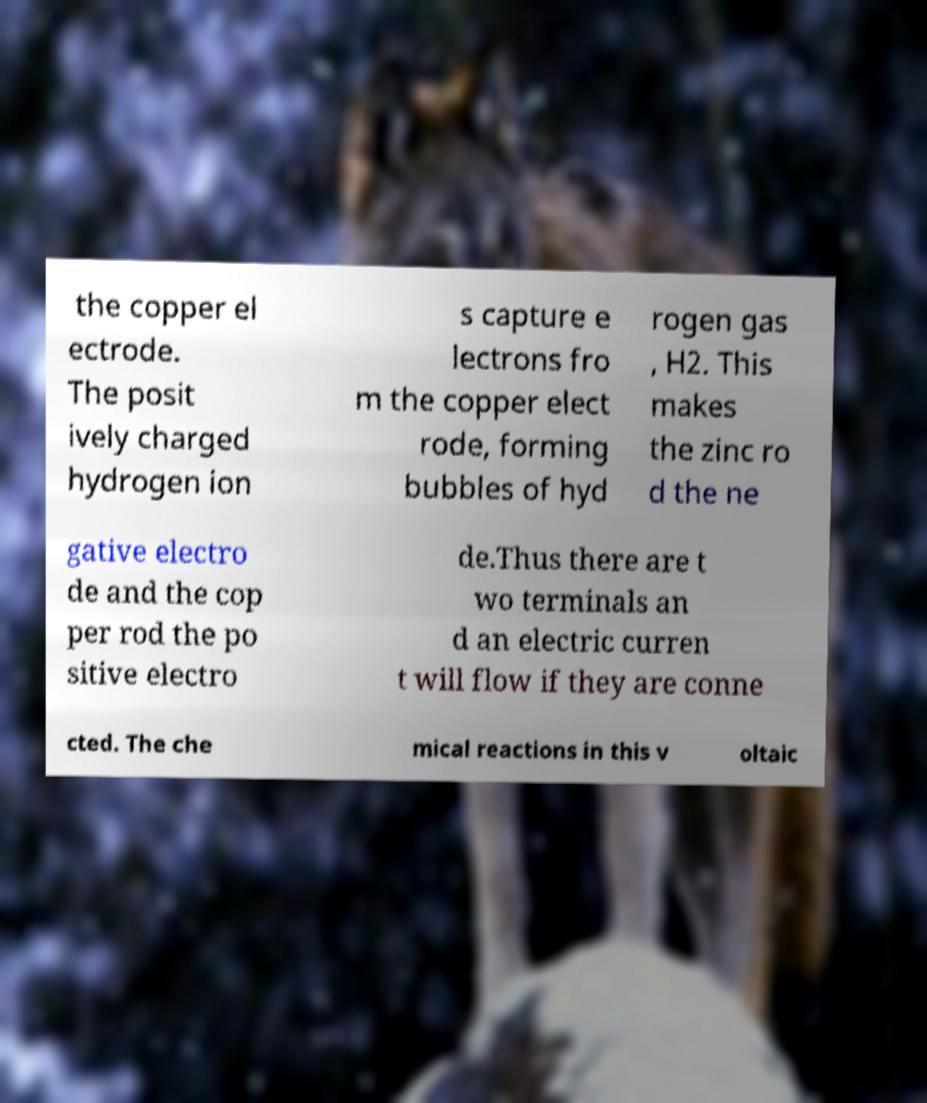For documentation purposes, I need the text within this image transcribed. Could you provide that? the copper el ectrode. The posit ively charged hydrogen ion s capture e lectrons fro m the copper elect rode, forming bubbles of hyd rogen gas , H2. This makes the zinc ro d the ne gative electro de and the cop per rod the po sitive electro de.Thus there are t wo terminals an d an electric curren t will flow if they are conne cted. The che mical reactions in this v oltaic 